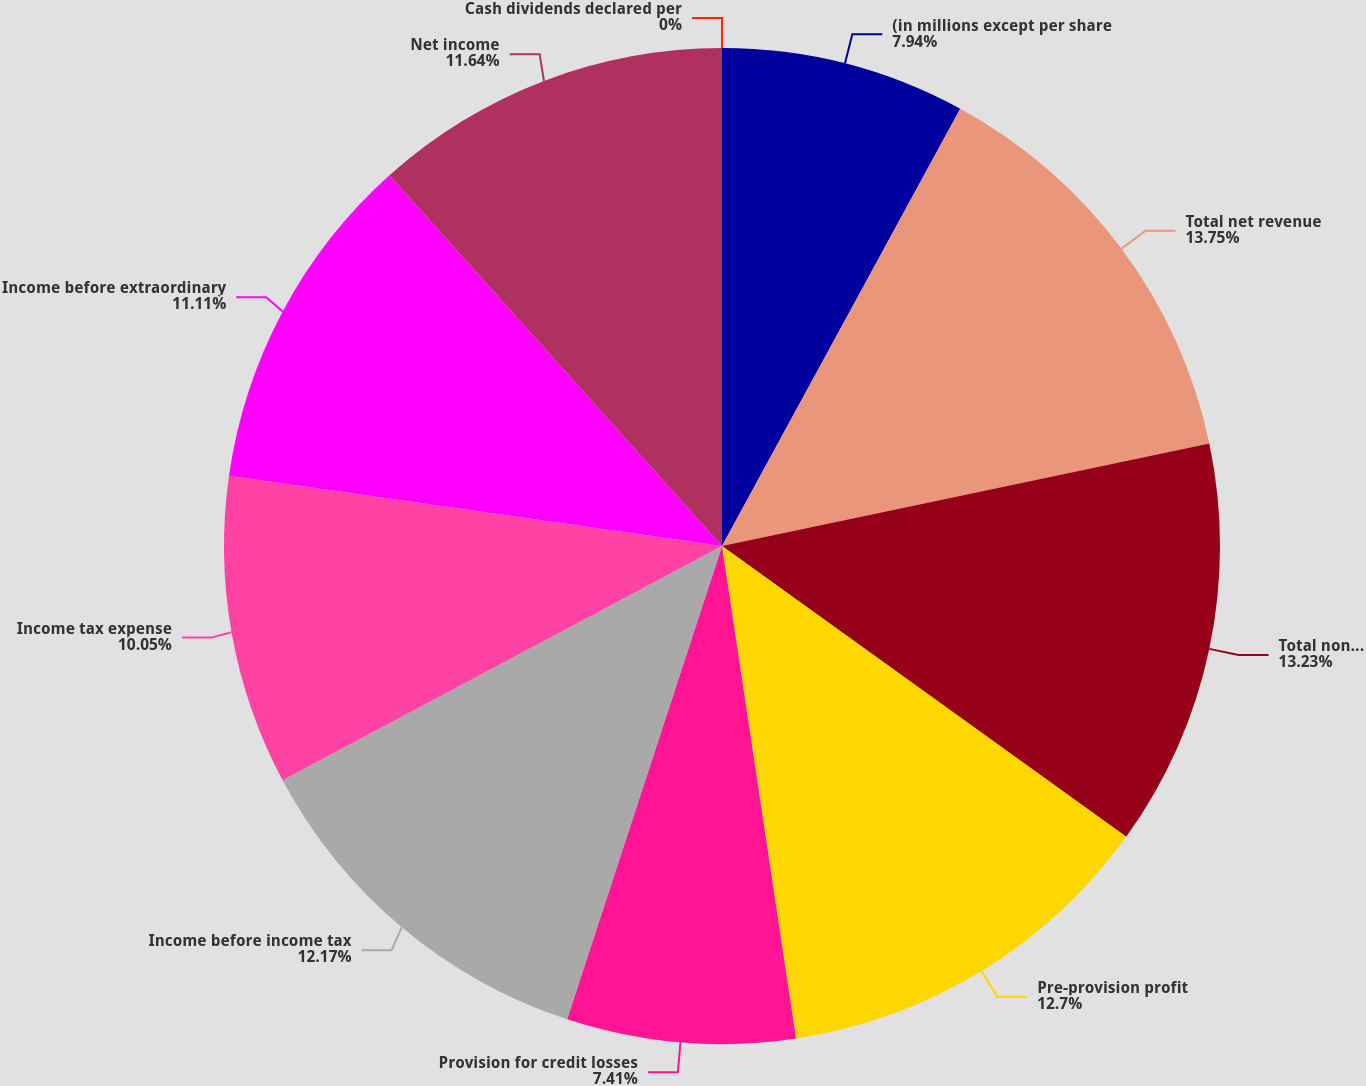<chart> <loc_0><loc_0><loc_500><loc_500><pie_chart><fcel>(in millions except per share<fcel>Total net revenue<fcel>Total noninterest expense<fcel>Pre-provision profit<fcel>Provision for credit losses<fcel>Income before income tax<fcel>Income tax expense<fcel>Income before extraordinary<fcel>Net income<fcel>Cash dividends declared per<nl><fcel>7.94%<fcel>13.76%<fcel>13.23%<fcel>12.7%<fcel>7.41%<fcel>12.17%<fcel>10.05%<fcel>11.11%<fcel>11.64%<fcel>0.0%<nl></chart> 